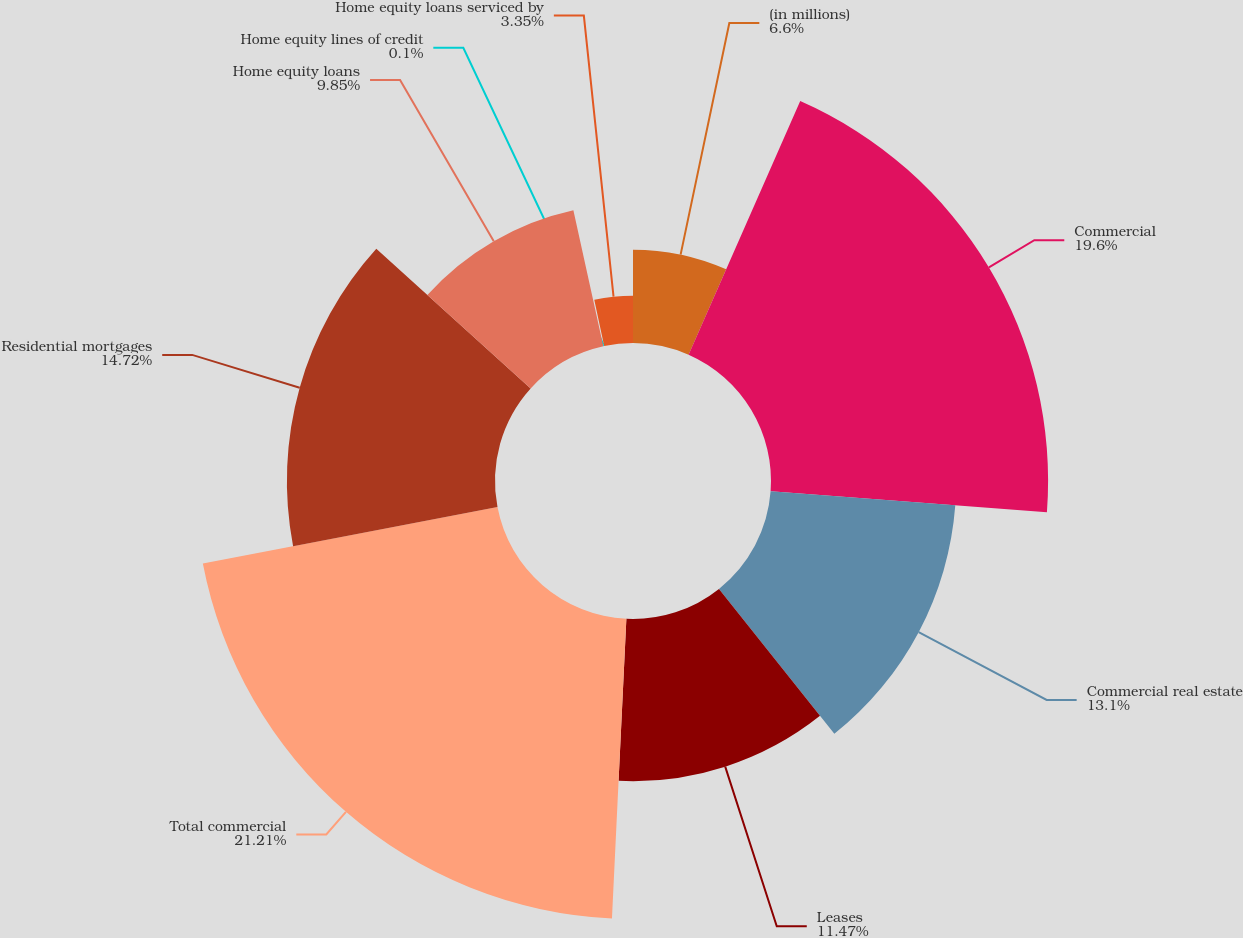<chart> <loc_0><loc_0><loc_500><loc_500><pie_chart><fcel>(in millions)<fcel>Commercial<fcel>Commercial real estate<fcel>Leases<fcel>Total commercial<fcel>Residential mortgages<fcel>Home equity loans<fcel>Home equity lines of credit<fcel>Home equity loans serviced by<nl><fcel>6.6%<fcel>19.6%<fcel>13.1%<fcel>11.47%<fcel>21.22%<fcel>14.72%<fcel>9.85%<fcel>0.1%<fcel>3.35%<nl></chart> 